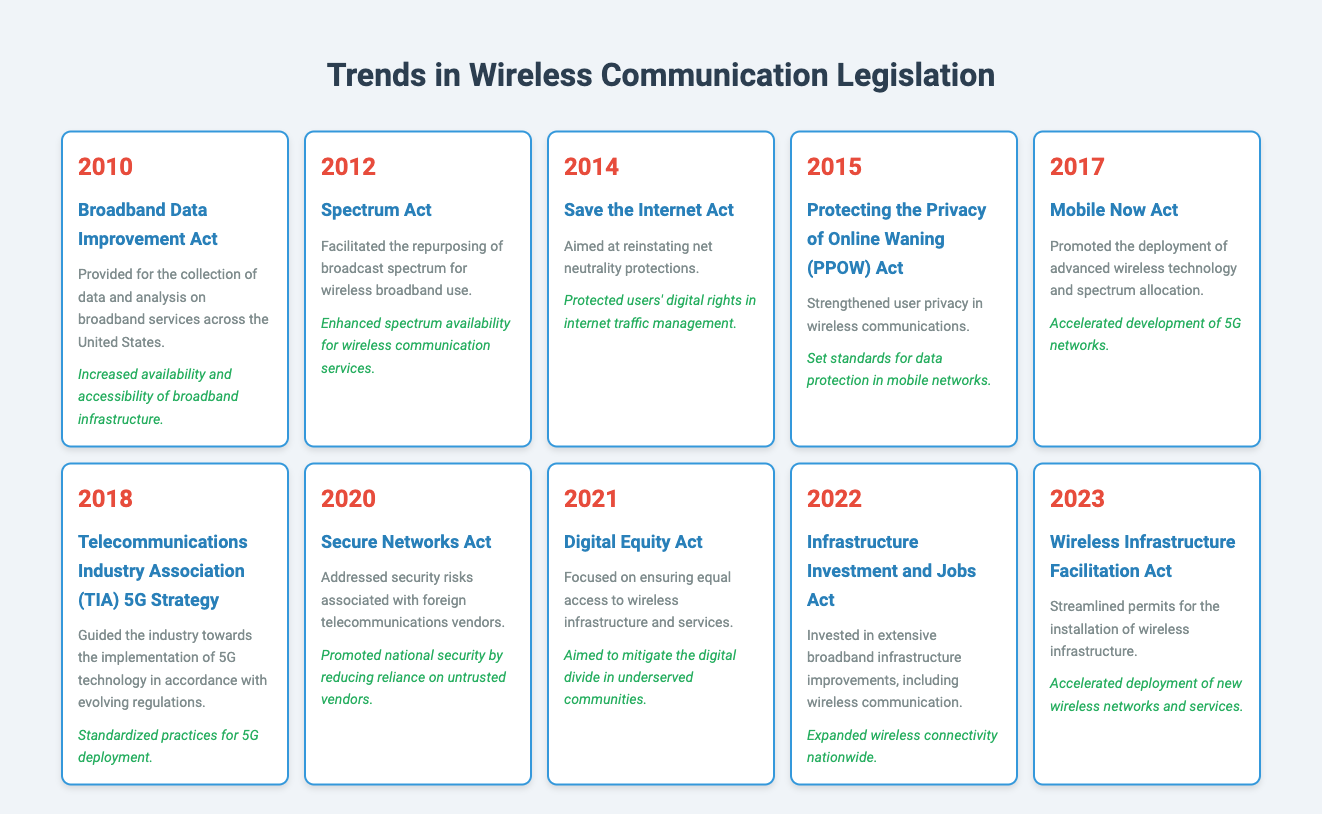What year was the Broadband Data Improvement Act enacted? According to the table, the year listed next to the Broadband Data Improvement Act is 2010.
Answer: 2010 How many pieces of legislation were enacted before 2018? From the table, the years before 2018 are 2010, 2012, 2014, 2015, and 2017. This totals 5 pieces of legislation.
Answer: 5 Did the Secure Networks Act address issues related to foreign telecommunications vendors? The description of the Secure Networks Act states it addressed security risks associated with foreign telecommunications vendors, confirming the fact as true.
Answer: Yes What impact did the Mobile Now Act have on 5G networks? The impact listed for the Mobile Now Act indicates that it accelerated the development of 5G networks, affirming its influence on this technology.
Answer: Accelerated development of 5G networks What is the difference in years between the enactment of the Digital Equity Act and the Save the Internet Act? The Digital Equity Act was enacted in 2021 and the Save the Internet Act was enacted in 2014. The difference is calculated as 2021 - 2014 = 7 years.
Answer: 7 years Did the Telecommunications Industry Association (TIA) 5G Strategy focus on standardizing practices for 5G deployment? The description confirms that it guided the industry towards the implementation of 5G technology in accordance with evolving regulations, aligning with the focus.
Answer: Yes Which legislation aimed to mitigate the digital divide in underserved communities? The table indicates that the Digital Equity Act, enacted in 2021, aimed to ensure equal access to wireless infrastructure and services, directly addressing the digital divide.
Answer: Digital Equity Act How many legislations specifically mention user privacy? Reviewing the table, only the Protecting the Privacy of Online Waning (PPOW) Act is focused on strengthening user privacy in wireless communications. Hence, there is 1 legislation.
Answer: 1 What percentage of the legislation listed is related to enhancing broadband infrastructure? There are three pieces of legislation focused on broadband infrastructure: the Broadband Data Improvement Act, the Infrastructure Investment and Jobs Act, and the Wireless Infrastructure Facilitation Act. With 10 total legislations, the percentage is (3/10)*100 = 30%.
Answer: 30% 